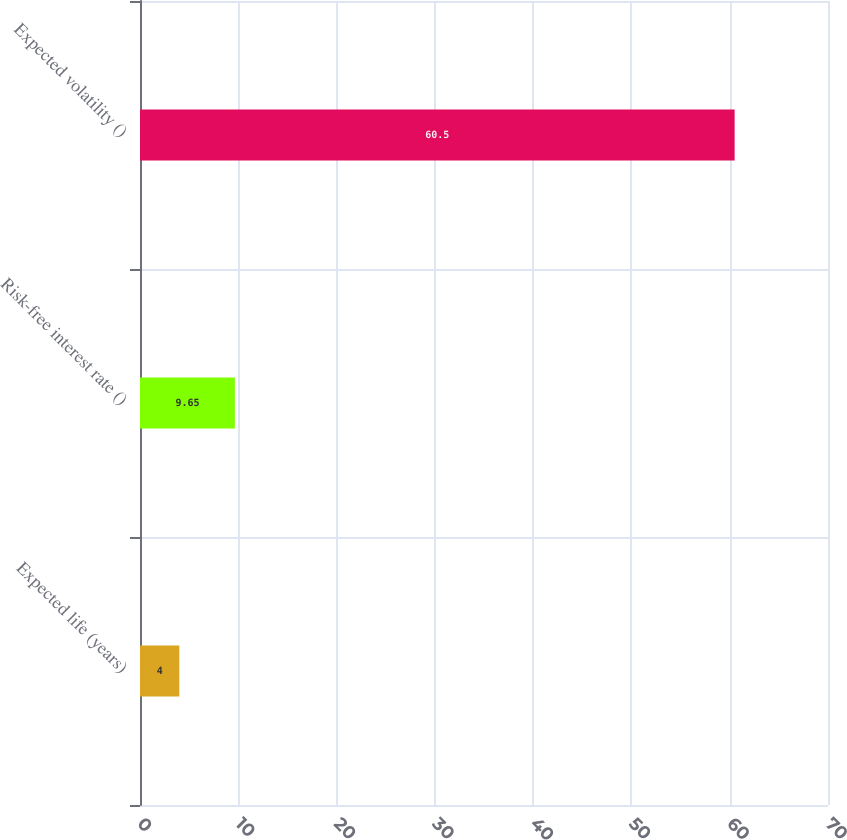Convert chart to OTSL. <chart><loc_0><loc_0><loc_500><loc_500><bar_chart><fcel>Expected life (years)<fcel>Risk-free interest rate ()<fcel>Expected volatility ()<nl><fcel>4<fcel>9.65<fcel>60.5<nl></chart> 